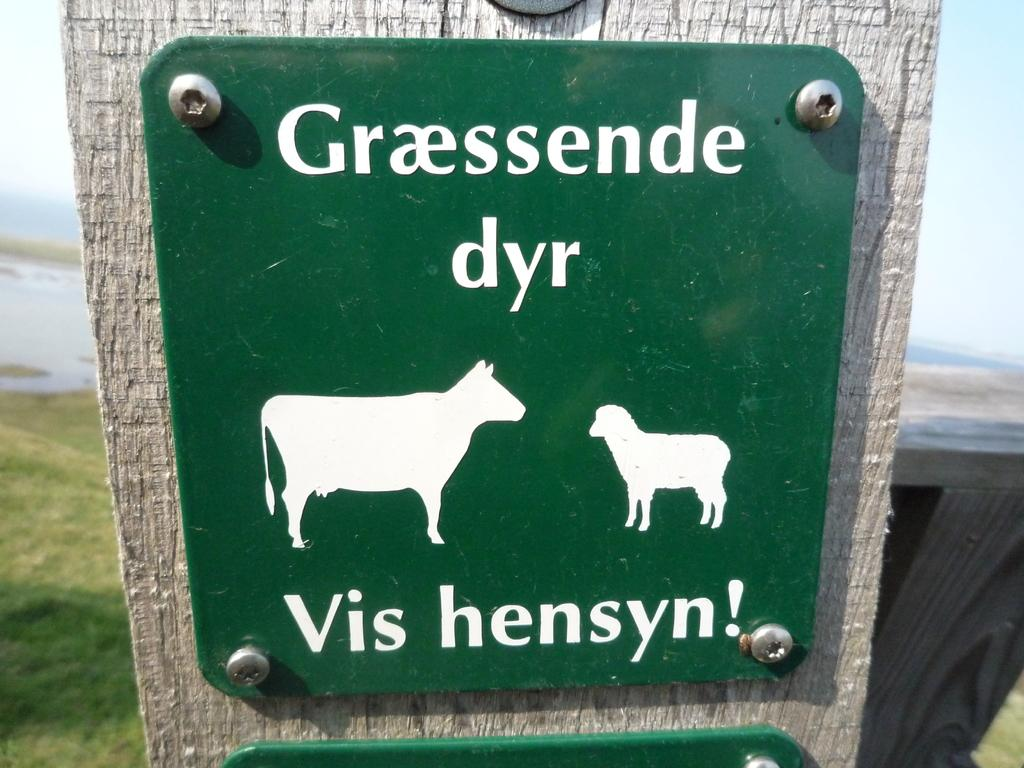What can be seen in the background of the image? Sky and grass are visible in the background of the image. What are the green boards in the image used for? The green boards in the image have depictions of animals and writing on them. What type of animals can be seen on the boards? The specific animals on the boards cannot be determined from the facts provided. How does the island depicted on the boards balance itself in the image? There is no island depicted on the boards in the image. 